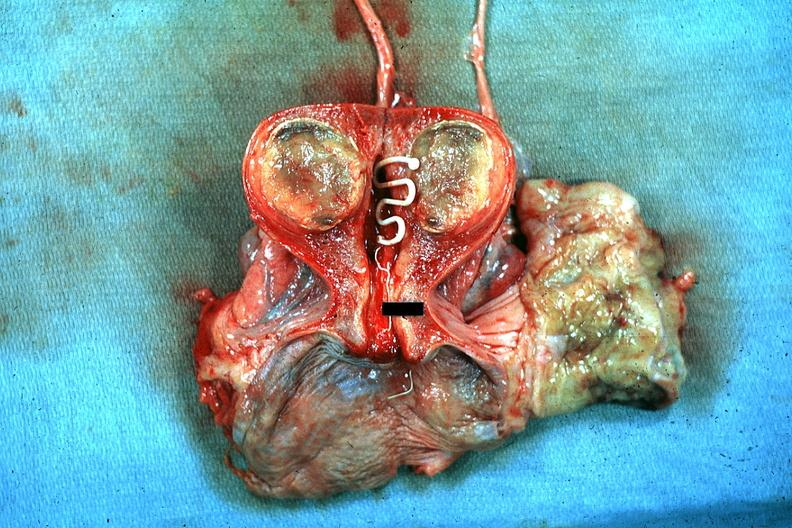what is present?
Answer the question using a single word or phrase. Intrauterine contraceptive device 